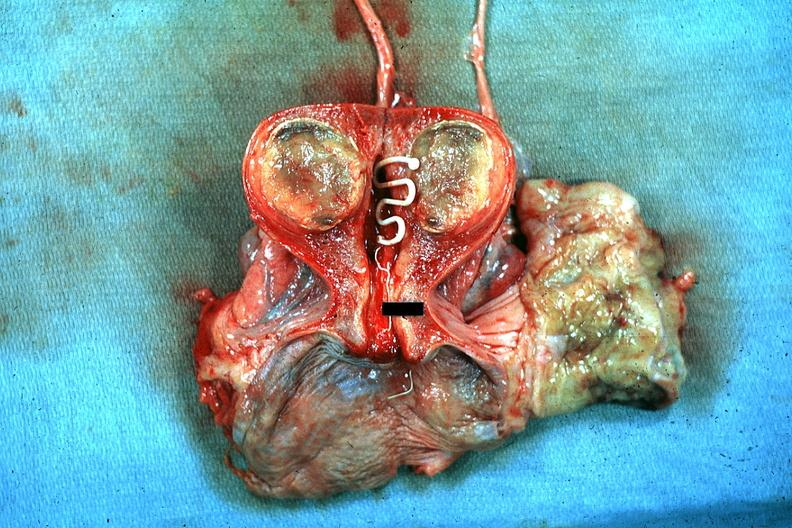what is present?
Answer the question using a single word or phrase. Intrauterine contraceptive device 